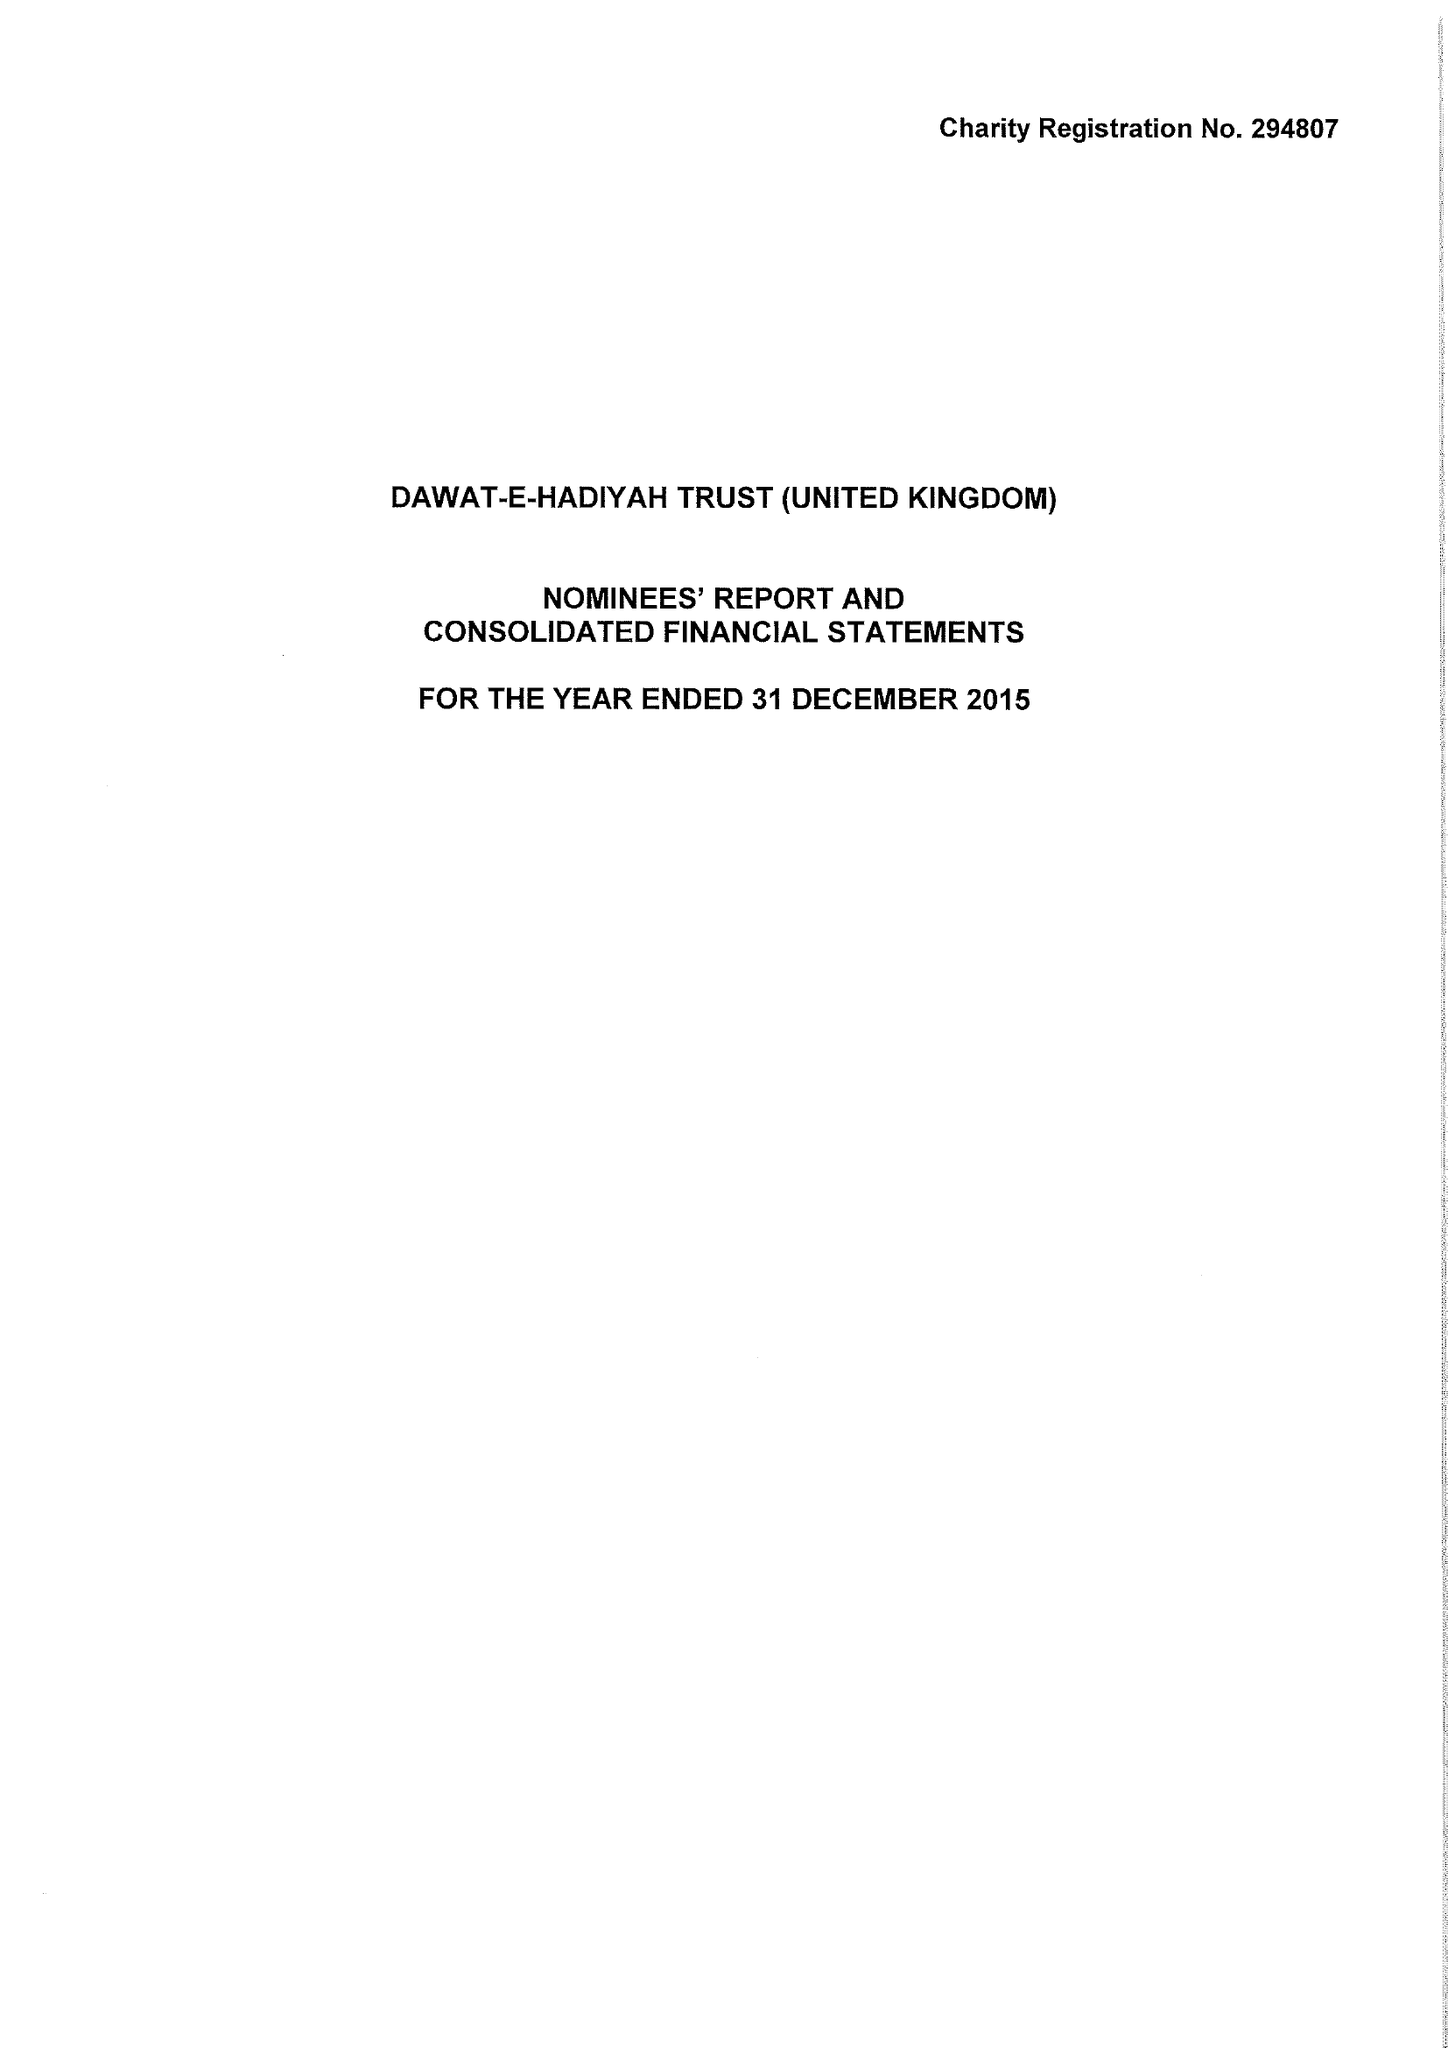What is the value for the charity_number?
Answer the question using a single word or phrase. 294807 